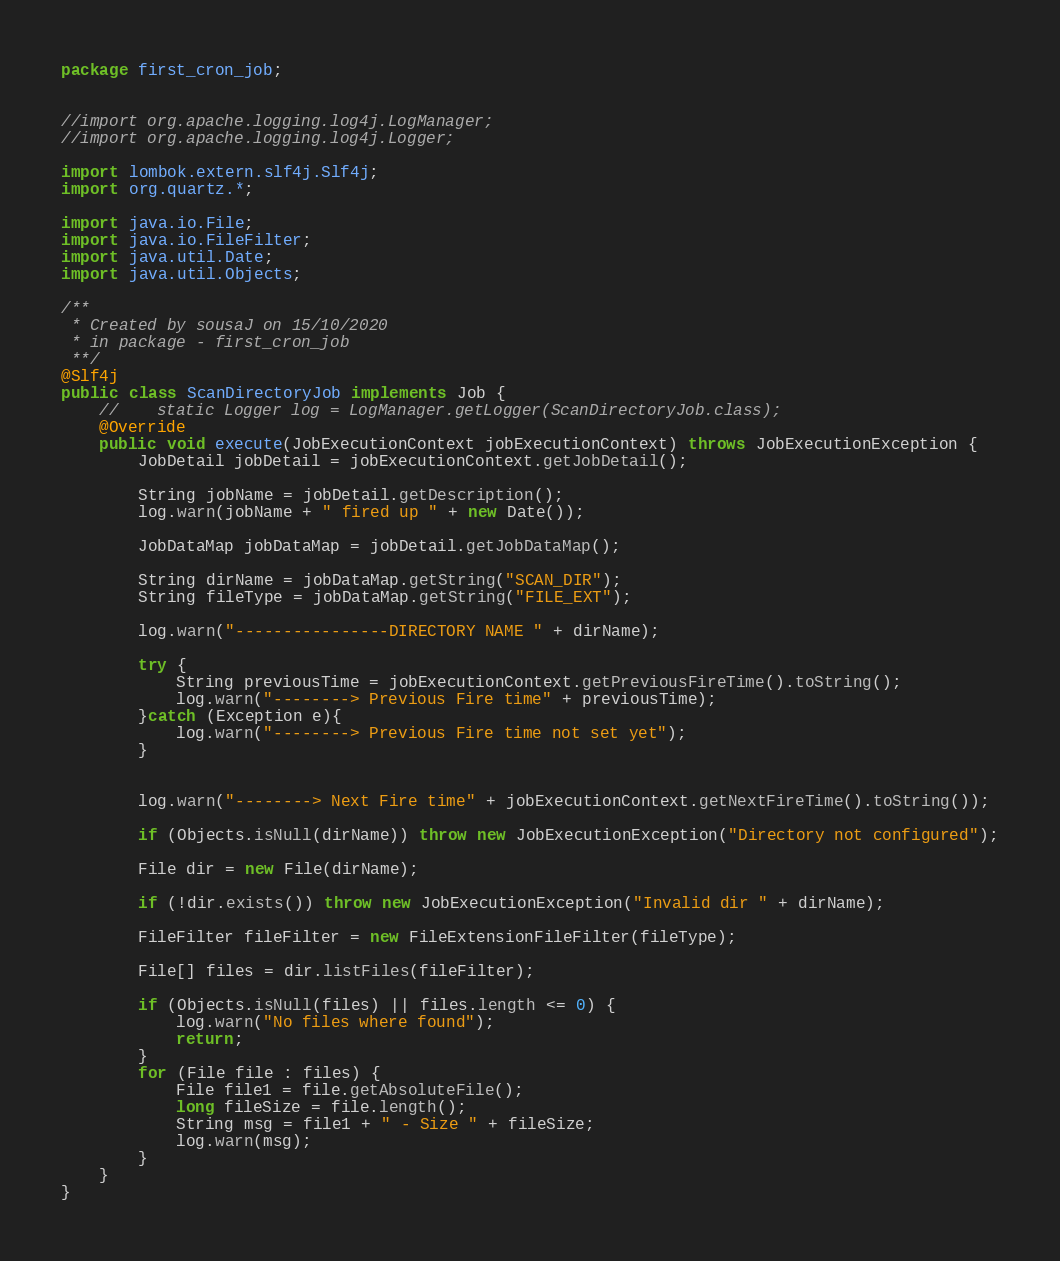Convert code to text. <code><loc_0><loc_0><loc_500><loc_500><_Java_>package first_cron_job;


//import org.apache.logging.log4j.LogManager;
//import org.apache.logging.log4j.Logger;

import lombok.extern.slf4j.Slf4j;
import org.quartz.*;

import java.io.File;
import java.io.FileFilter;
import java.util.Date;
import java.util.Objects;

/**
 * Created by sousaJ on 15/10/2020
 * in package - first_cron_job
 **/
@Slf4j
public class ScanDirectoryJob implements Job {
    //    static Logger log = LogManager.getLogger(ScanDirectoryJob.class);
    @Override
    public void execute(JobExecutionContext jobExecutionContext) throws JobExecutionException {
        JobDetail jobDetail = jobExecutionContext.getJobDetail();

        String jobName = jobDetail.getDescription();
        log.warn(jobName + " fired up " + new Date());

        JobDataMap jobDataMap = jobDetail.getJobDataMap();

        String dirName = jobDataMap.getString("SCAN_DIR");
        String fileType = jobDataMap.getString("FILE_EXT");

        log.warn("----------------DIRECTORY NAME " + dirName);

        try {
            String previousTime = jobExecutionContext.getPreviousFireTime().toString();
            log.warn("--------> Previous Fire time" + previousTime);
        }catch (Exception e){
            log.warn("--------> Previous Fire time not set yet");
        }


        log.warn("--------> Next Fire time" + jobExecutionContext.getNextFireTime().toString());

        if (Objects.isNull(dirName)) throw new JobExecutionException("Directory not configured");

        File dir = new File(dirName);

        if (!dir.exists()) throw new JobExecutionException("Invalid dir " + dirName);

        FileFilter fileFilter = new FileExtensionFileFilter(fileType);

        File[] files = dir.listFiles(fileFilter);

        if (Objects.isNull(files) || files.length <= 0) {
            log.warn("No files where found");
            return;
        }
        for (File file : files) {
            File file1 = file.getAbsoluteFile();
            long fileSize = file.length();
            String msg = file1 + " - Size " + fileSize;
            log.warn(msg);
        }
    }
}

</code> 